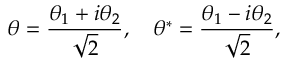<formula> <loc_0><loc_0><loc_500><loc_500>\theta = { \frac { \theta _ { 1 } + i \theta _ { 2 } } { \sqrt { 2 } } } , \quad \theta ^ { * } = { \frac { \theta _ { 1 } - i \theta _ { 2 } } { \sqrt { 2 } } } ,</formula> 